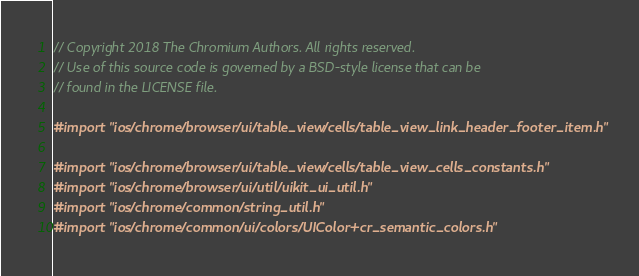<code> <loc_0><loc_0><loc_500><loc_500><_ObjectiveC_>// Copyright 2018 The Chromium Authors. All rights reserved.
// Use of this source code is governed by a BSD-style license that can be
// found in the LICENSE file.

#import "ios/chrome/browser/ui/table_view/cells/table_view_link_header_footer_item.h"

#import "ios/chrome/browser/ui/table_view/cells/table_view_cells_constants.h"
#import "ios/chrome/browser/ui/util/uikit_ui_util.h"
#import "ios/chrome/common/string_util.h"
#import "ios/chrome/common/ui/colors/UIColor+cr_semantic_colors.h"</code> 